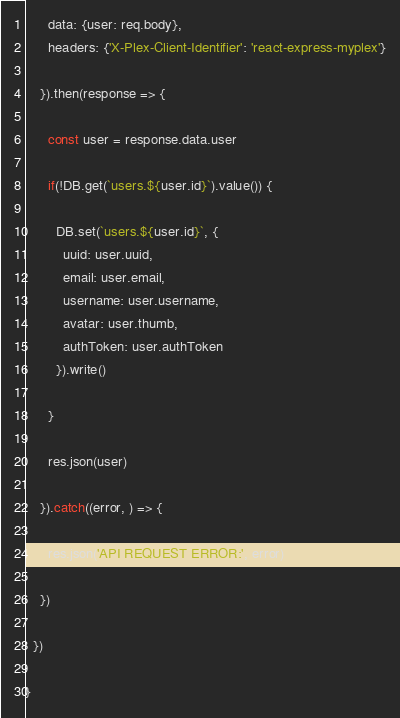<code> <loc_0><loc_0><loc_500><loc_500><_JavaScript_>      data: {user: req.body},
      headers: {'X-Plex-Client-Identifier': 'react-express-myplex'}

    }).then(response => {

      const user = response.data.user

      if(!DB.get(`users.${user.id}`).value()) {

        DB.set(`users.${user.id}`, {
          uuid: user.uuid,
          email: user.email,
          username: user.username,
          avatar: user.thumb,
          authToken: user.authToken
        }).write()

      }

      res.json(user)

    }).catch((error, ) => {

      res.json('API REQUEST ERROR:', error)

    })
  
  })

}</code> 